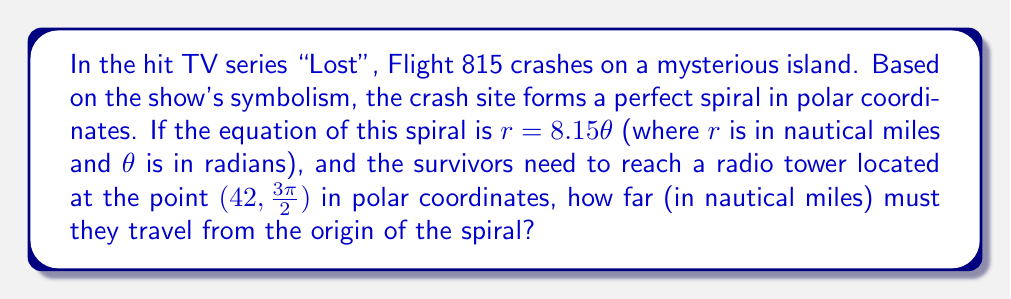Can you answer this question? To solve this problem, we need to follow these steps:

1) First, we need to understand that the point $(42, \frac{3\pi}{2})$ in polar coordinates represents the radio tower's location. The first number (42) is the radial distance from the origin, and the second number $(\frac{3\pi}{2})$ is the angle in radians.

2) We need to determine if this point lies on the spiral. To do this, we can substitute the $\theta$ value into the equation of the spiral:

   $r = 8.15\theta$
   $r = 8.15 \cdot \frac{3\pi}{2} = 12.225\pi \approx 38.41$ nautical miles

3) This is not equal to 42, so the radio tower does not lie on the spiral.

4) To find the distance from the origin to the radio tower, we can use the given radial distance directly, which is 42 nautical miles.

5) The question asks for the distance in nautical miles, so no further conversion is needed.

This problem incorporates several "Lost" references: 
- The numbers 8, 15, and 42 are part of the mysterious sequence 4, 8, 15, 16, 23, 42 that appears throughout the series.
- The spiral shape could symbolize the time travel and looping narratives in the show.
- The radio tower is a key location in the series.
Answer: 42 nautical miles 